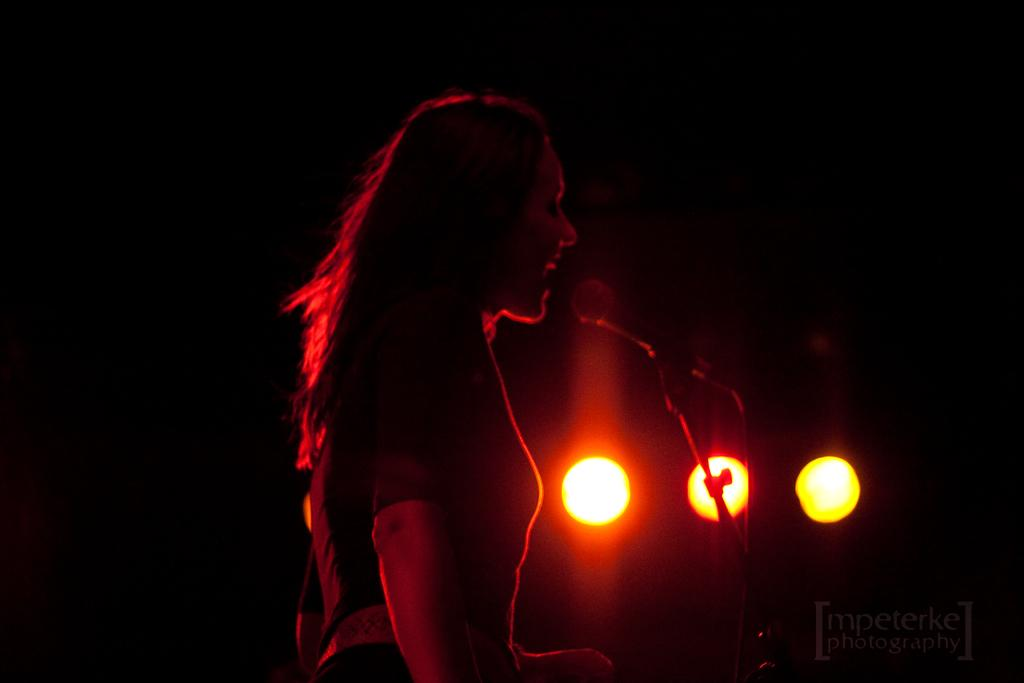Who is present in the image? There is a lady in the image. What object is visible in the image that is typically used for amplifying sound? There is a microphone in the image. What structure can be seen in the image that might be used for holding or supporting something? There is a stand in the image. What can be seen in the background of the image that provides illumination? There are lights in the background of the image. How would you describe the overall appearance of the background in the image? The background of the image has a dark view. What type of building is visible in the image? There is no building present in the image. What badge or identification is the lady wearing in the image? There is no badge or identification visible on the lady in the image. 